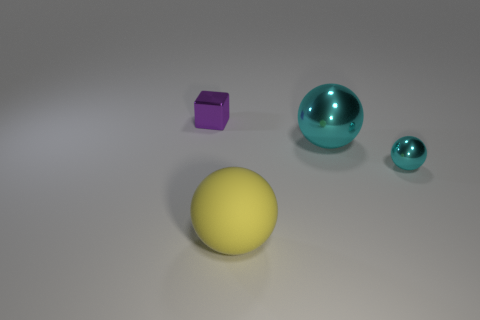There is a small metal object in front of the small cube; is its shape the same as the purple object?
Give a very brief answer. No. What color is the small shiny block?
Your answer should be compact. Purple. What is the shape of the big metallic thing that is the same color as the tiny metal sphere?
Keep it short and to the point. Sphere. Is there a gray cylinder?
Give a very brief answer. No. What is the size of the cyan thing that is made of the same material as the large cyan sphere?
Your response must be concise. Small. There is a small thing left of the cyan object that is in front of the cyan sphere that is to the left of the small metal sphere; what shape is it?
Your answer should be very brief. Cube. Are there the same number of yellow objects that are behind the big yellow matte sphere and small gray matte cubes?
Keep it short and to the point. Yes. There is a sphere that is the same color as the large shiny thing; what is its size?
Offer a very short reply. Small. Does the tiny purple metallic object have the same shape as the large yellow object?
Your answer should be very brief. No. How many objects are either large objects that are behind the large matte object or brown cylinders?
Ensure brevity in your answer.  1. 